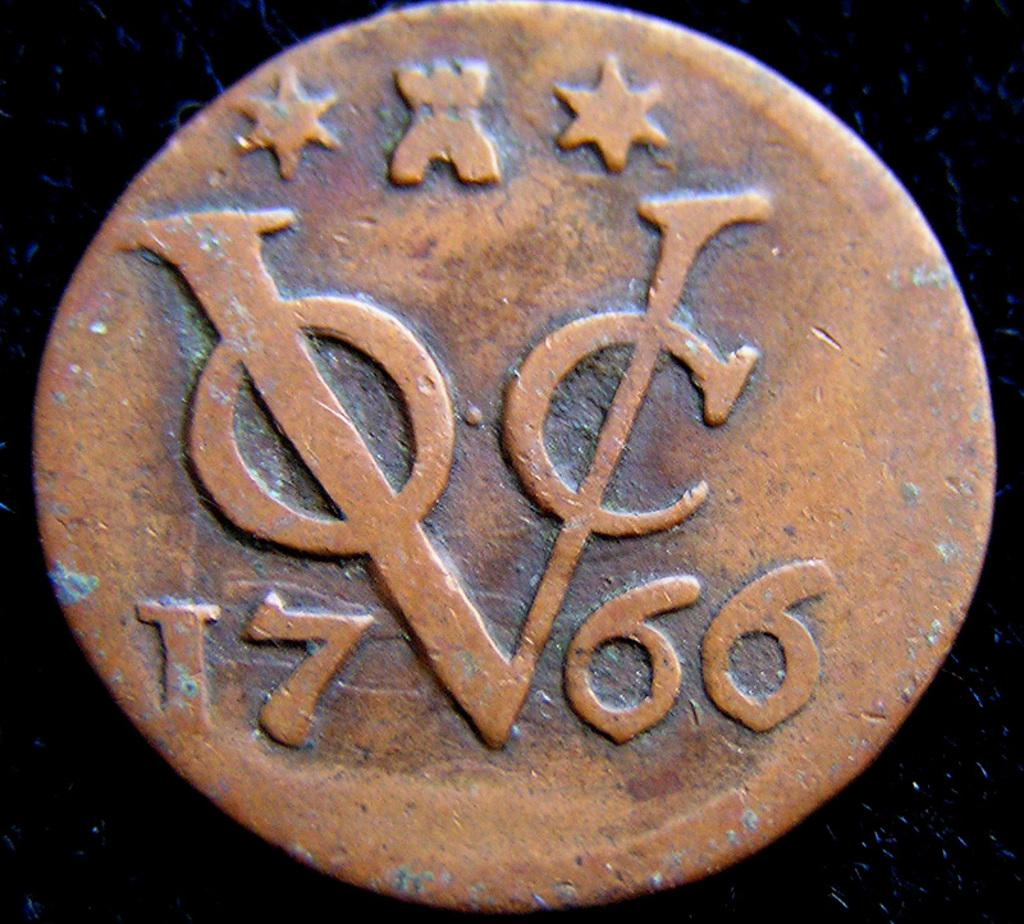What is the main object in the image? There is a coin in the image. What can be seen on the surface of the coin? There are carvings on the coin. What type of screw is holding the bridge together in the image? There is no bridge or screw present in the image; it only features a coin with carvings. 